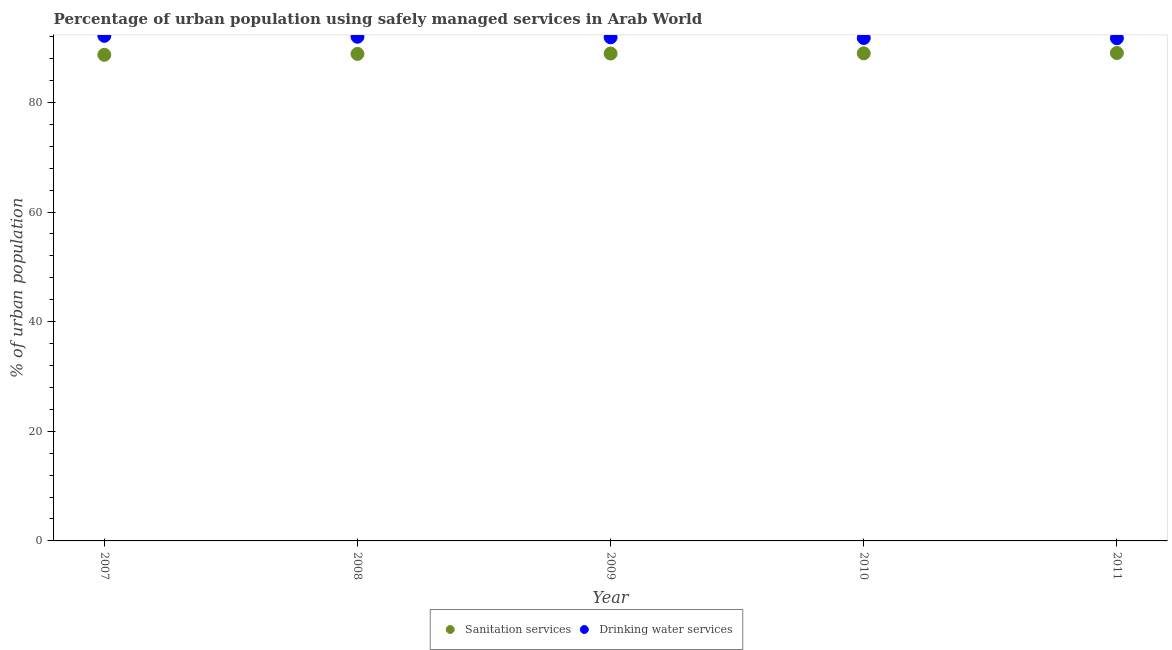Is the number of dotlines equal to the number of legend labels?
Offer a terse response. Yes. What is the percentage of urban population who used sanitation services in 2010?
Provide a short and direct response. 88.95. Across all years, what is the maximum percentage of urban population who used sanitation services?
Your response must be concise. 89.01. Across all years, what is the minimum percentage of urban population who used sanitation services?
Provide a succinct answer. 88.68. In which year was the percentage of urban population who used sanitation services maximum?
Offer a very short reply. 2011. In which year was the percentage of urban population who used sanitation services minimum?
Give a very brief answer. 2007. What is the total percentage of urban population who used sanitation services in the graph?
Give a very brief answer. 444.4. What is the difference between the percentage of urban population who used sanitation services in 2008 and that in 2009?
Your response must be concise. -0.07. What is the difference between the percentage of urban population who used sanitation services in 2007 and the percentage of urban population who used drinking water services in 2010?
Keep it short and to the point. -3.07. What is the average percentage of urban population who used drinking water services per year?
Provide a short and direct response. 91.89. In the year 2008, what is the difference between the percentage of urban population who used sanitation services and percentage of urban population who used drinking water services?
Provide a succinct answer. -3.14. In how many years, is the percentage of urban population who used drinking water services greater than 28 %?
Make the answer very short. 5. What is the ratio of the percentage of urban population who used sanitation services in 2007 to that in 2010?
Ensure brevity in your answer.  1. What is the difference between the highest and the second highest percentage of urban population who used drinking water services?
Your answer should be very brief. 0.16. What is the difference between the highest and the lowest percentage of urban population who used sanitation services?
Offer a terse response. 0.33. Is the sum of the percentage of urban population who used drinking water services in 2008 and 2010 greater than the maximum percentage of urban population who used sanitation services across all years?
Offer a terse response. Yes. Does the percentage of urban population who used sanitation services monotonically increase over the years?
Give a very brief answer. Yes. Is the percentage of urban population who used drinking water services strictly less than the percentage of urban population who used sanitation services over the years?
Your answer should be compact. No. How many dotlines are there?
Ensure brevity in your answer.  2. Does the graph contain grids?
Give a very brief answer. No. Where does the legend appear in the graph?
Make the answer very short. Bottom center. How many legend labels are there?
Offer a very short reply. 2. How are the legend labels stacked?
Offer a very short reply. Horizontal. What is the title of the graph?
Your answer should be very brief. Percentage of urban population using safely managed services in Arab World. Does "Female labourers" appear as one of the legend labels in the graph?
Offer a very short reply. No. What is the label or title of the Y-axis?
Keep it short and to the point. % of urban population. What is the % of urban population of Sanitation services in 2007?
Give a very brief answer. 88.68. What is the % of urban population in Drinking water services in 2007?
Provide a succinct answer. 92.15. What is the % of urban population of Sanitation services in 2008?
Make the answer very short. 88.85. What is the % of urban population in Drinking water services in 2008?
Provide a short and direct response. 91.98. What is the % of urban population of Sanitation services in 2009?
Offer a terse response. 88.91. What is the % of urban population in Drinking water services in 2009?
Provide a short and direct response. 91.87. What is the % of urban population in Sanitation services in 2010?
Keep it short and to the point. 88.95. What is the % of urban population in Drinking water services in 2010?
Make the answer very short. 91.75. What is the % of urban population in Sanitation services in 2011?
Keep it short and to the point. 89.01. What is the % of urban population of Drinking water services in 2011?
Offer a terse response. 91.71. Across all years, what is the maximum % of urban population in Sanitation services?
Provide a succinct answer. 89.01. Across all years, what is the maximum % of urban population of Drinking water services?
Your answer should be very brief. 92.15. Across all years, what is the minimum % of urban population of Sanitation services?
Keep it short and to the point. 88.68. Across all years, what is the minimum % of urban population in Drinking water services?
Your answer should be very brief. 91.71. What is the total % of urban population of Sanitation services in the graph?
Your answer should be compact. 444.4. What is the total % of urban population of Drinking water services in the graph?
Offer a very short reply. 459.46. What is the difference between the % of urban population of Sanitation services in 2007 and that in 2008?
Give a very brief answer. -0.17. What is the difference between the % of urban population of Drinking water services in 2007 and that in 2008?
Make the answer very short. 0.16. What is the difference between the % of urban population of Sanitation services in 2007 and that in 2009?
Keep it short and to the point. -0.23. What is the difference between the % of urban population in Drinking water services in 2007 and that in 2009?
Offer a very short reply. 0.27. What is the difference between the % of urban population in Sanitation services in 2007 and that in 2010?
Your response must be concise. -0.27. What is the difference between the % of urban population of Drinking water services in 2007 and that in 2010?
Your response must be concise. 0.4. What is the difference between the % of urban population in Sanitation services in 2007 and that in 2011?
Give a very brief answer. -0.33. What is the difference between the % of urban population in Drinking water services in 2007 and that in 2011?
Ensure brevity in your answer.  0.44. What is the difference between the % of urban population in Sanitation services in 2008 and that in 2009?
Offer a terse response. -0.07. What is the difference between the % of urban population of Drinking water services in 2008 and that in 2009?
Give a very brief answer. 0.11. What is the difference between the % of urban population in Sanitation services in 2008 and that in 2010?
Your response must be concise. -0.1. What is the difference between the % of urban population in Drinking water services in 2008 and that in 2010?
Your answer should be very brief. 0.23. What is the difference between the % of urban population of Sanitation services in 2008 and that in 2011?
Provide a short and direct response. -0.16. What is the difference between the % of urban population in Drinking water services in 2008 and that in 2011?
Your response must be concise. 0.28. What is the difference between the % of urban population in Sanitation services in 2009 and that in 2010?
Provide a short and direct response. -0.04. What is the difference between the % of urban population in Drinking water services in 2009 and that in 2010?
Keep it short and to the point. 0.12. What is the difference between the % of urban population in Sanitation services in 2009 and that in 2011?
Give a very brief answer. -0.1. What is the difference between the % of urban population in Drinking water services in 2009 and that in 2011?
Offer a very short reply. 0.17. What is the difference between the % of urban population of Sanitation services in 2010 and that in 2011?
Provide a short and direct response. -0.06. What is the difference between the % of urban population of Drinking water services in 2010 and that in 2011?
Your answer should be very brief. 0.04. What is the difference between the % of urban population in Sanitation services in 2007 and the % of urban population in Drinking water services in 2008?
Your response must be concise. -3.3. What is the difference between the % of urban population in Sanitation services in 2007 and the % of urban population in Drinking water services in 2009?
Your answer should be very brief. -3.19. What is the difference between the % of urban population in Sanitation services in 2007 and the % of urban population in Drinking water services in 2010?
Ensure brevity in your answer.  -3.07. What is the difference between the % of urban population in Sanitation services in 2007 and the % of urban population in Drinking water services in 2011?
Keep it short and to the point. -3.03. What is the difference between the % of urban population in Sanitation services in 2008 and the % of urban population in Drinking water services in 2009?
Give a very brief answer. -3.03. What is the difference between the % of urban population in Sanitation services in 2008 and the % of urban population in Drinking water services in 2010?
Ensure brevity in your answer.  -2.9. What is the difference between the % of urban population of Sanitation services in 2008 and the % of urban population of Drinking water services in 2011?
Offer a terse response. -2.86. What is the difference between the % of urban population of Sanitation services in 2009 and the % of urban population of Drinking water services in 2010?
Give a very brief answer. -2.84. What is the difference between the % of urban population of Sanitation services in 2009 and the % of urban population of Drinking water services in 2011?
Give a very brief answer. -2.79. What is the difference between the % of urban population in Sanitation services in 2010 and the % of urban population in Drinking water services in 2011?
Make the answer very short. -2.76. What is the average % of urban population of Sanitation services per year?
Offer a terse response. 88.88. What is the average % of urban population in Drinking water services per year?
Provide a short and direct response. 91.89. In the year 2007, what is the difference between the % of urban population in Sanitation services and % of urban population in Drinking water services?
Offer a very short reply. -3.46. In the year 2008, what is the difference between the % of urban population of Sanitation services and % of urban population of Drinking water services?
Make the answer very short. -3.13. In the year 2009, what is the difference between the % of urban population of Sanitation services and % of urban population of Drinking water services?
Your answer should be compact. -2.96. In the year 2010, what is the difference between the % of urban population of Sanitation services and % of urban population of Drinking water services?
Your answer should be very brief. -2.8. In the year 2011, what is the difference between the % of urban population of Sanitation services and % of urban population of Drinking water services?
Give a very brief answer. -2.7. What is the ratio of the % of urban population in Sanitation services in 2007 to that in 2009?
Give a very brief answer. 1. What is the ratio of the % of urban population in Drinking water services in 2007 to that in 2009?
Your answer should be very brief. 1. What is the ratio of the % of urban population of Sanitation services in 2007 to that in 2010?
Your response must be concise. 1. What is the ratio of the % of urban population of Sanitation services in 2007 to that in 2011?
Make the answer very short. 1. What is the ratio of the % of urban population in Sanitation services in 2008 to that in 2009?
Your answer should be very brief. 1. What is the ratio of the % of urban population of Drinking water services in 2008 to that in 2009?
Keep it short and to the point. 1. What is the ratio of the % of urban population in Drinking water services in 2008 to that in 2010?
Ensure brevity in your answer.  1. What is the ratio of the % of urban population of Drinking water services in 2008 to that in 2011?
Make the answer very short. 1. What is the ratio of the % of urban population of Sanitation services in 2009 to that in 2011?
Give a very brief answer. 1. What is the ratio of the % of urban population of Drinking water services in 2009 to that in 2011?
Provide a succinct answer. 1. What is the difference between the highest and the second highest % of urban population of Sanitation services?
Provide a succinct answer. 0.06. What is the difference between the highest and the second highest % of urban population in Drinking water services?
Keep it short and to the point. 0.16. What is the difference between the highest and the lowest % of urban population in Sanitation services?
Provide a succinct answer. 0.33. What is the difference between the highest and the lowest % of urban population of Drinking water services?
Offer a terse response. 0.44. 